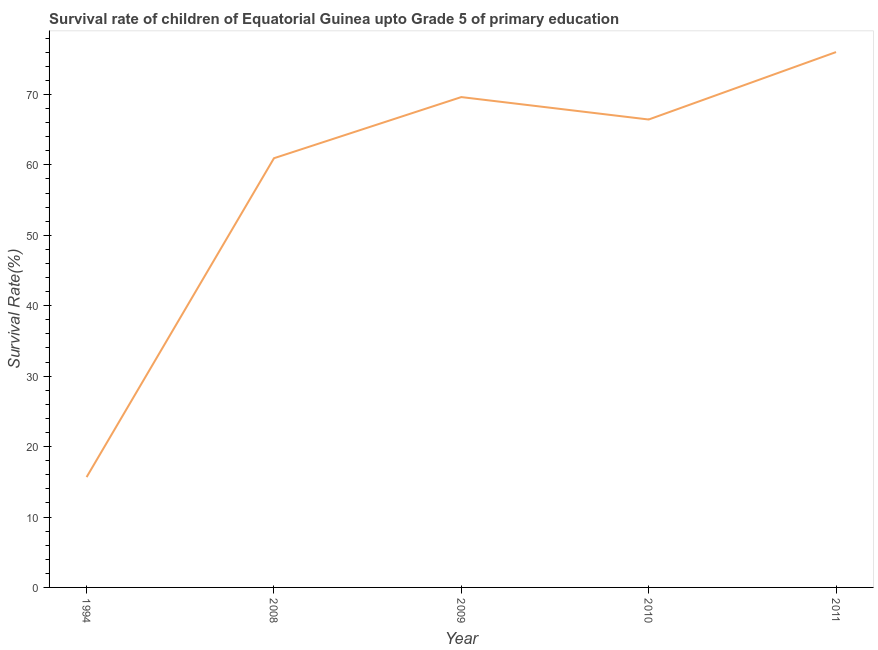What is the survival rate in 2009?
Your response must be concise. 69.63. Across all years, what is the maximum survival rate?
Make the answer very short. 76.02. Across all years, what is the minimum survival rate?
Keep it short and to the point. 15.67. In which year was the survival rate maximum?
Offer a terse response. 2011. What is the sum of the survival rate?
Provide a short and direct response. 288.7. What is the difference between the survival rate in 1994 and 2011?
Give a very brief answer. -60.35. What is the average survival rate per year?
Your answer should be compact. 57.74. What is the median survival rate?
Your answer should be very brief. 66.44. In how many years, is the survival rate greater than 26 %?
Make the answer very short. 4. Do a majority of the years between 2011 and 1994 (inclusive) have survival rate greater than 26 %?
Provide a short and direct response. Yes. What is the ratio of the survival rate in 2009 to that in 2011?
Your response must be concise. 0.92. What is the difference between the highest and the second highest survival rate?
Your response must be concise. 6.39. Is the sum of the survival rate in 1994 and 2011 greater than the maximum survival rate across all years?
Your answer should be very brief. Yes. What is the difference between the highest and the lowest survival rate?
Keep it short and to the point. 60.35. How many lines are there?
Make the answer very short. 1. Are the values on the major ticks of Y-axis written in scientific E-notation?
Provide a succinct answer. No. Does the graph contain any zero values?
Provide a short and direct response. No. What is the title of the graph?
Provide a succinct answer. Survival rate of children of Equatorial Guinea upto Grade 5 of primary education. What is the label or title of the X-axis?
Keep it short and to the point. Year. What is the label or title of the Y-axis?
Your answer should be very brief. Survival Rate(%). What is the Survival Rate(%) in 1994?
Give a very brief answer. 15.67. What is the Survival Rate(%) of 2008?
Your response must be concise. 60.94. What is the Survival Rate(%) of 2009?
Your answer should be compact. 69.63. What is the Survival Rate(%) of 2010?
Provide a short and direct response. 66.44. What is the Survival Rate(%) in 2011?
Offer a very short reply. 76.02. What is the difference between the Survival Rate(%) in 1994 and 2008?
Provide a succinct answer. -45.28. What is the difference between the Survival Rate(%) in 1994 and 2009?
Your answer should be very brief. -53.96. What is the difference between the Survival Rate(%) in 1994 and 2010?
Make the answer very short. -50.78. What is the difference between the Survival Rate(%) in 1994 and 2011?
Your response must be concise. -60.35. What is the difference between the Survival Rate(%) in 2008 and 2009?
Give a very brief answer. -8.68. What is the difference between the Survival Rate(%) in 2008 and 2010?
Provide a short and direct response. -5.5. What is the difference between the Survival Rate(%) in 2008 and 2011?
Give a very brief answer. -15.07. What is the difference between the Survival Rate(%) in 2009 and 2010?
Ensure brevity in your answer.  3.18. What is the difference between the Survival Rate(%) in 2009 and 2011?
Offer a very short reply. -6.39. What is the difference between the Survival Rate(%) in 2010 and 2011?
Provide a short and direct response. -9.58. What is the ratio of the Survival Rate(%) in 1994 to that in 2008?
Offer a terse response. 0.26. What is the ratio of the Survival Rate(%) in 1994 to that in 2009?
Keep it short and to the point. 0.23. What is the ratio of the Survival Rate(%) in 1994 to that in 2010?
Give a very brief answer. 0.24. What is the ratio of the Survival Rate(%) in 1994 to that in 2011?
Provide a short and direct response. 0.21. What is the ratio of the Survival Rate(%) in 2008 to that in 2009?
Provide a succinct answer. 0.88. What is the ratio of the Survival Rate(%) in 2008 to that in 2010?
Offer a terse response. 0.92. What is the ratio of the Survival Rate(%) in 2008 to that in 2011?
Offer a terse response. 0.8. What is the ratio of the Survival Rate(%) in 2009 to that in 2010?
Give a very brief answer. 1.05. What is the ratio of the Survival Rate(%) in 2009 to that in 2011?
Keep it short and to the point. 0.92. What is the ratio of the Survival Rate(%) in 2010 to that in 2011?
Your answer should be very brief. 0.87. 